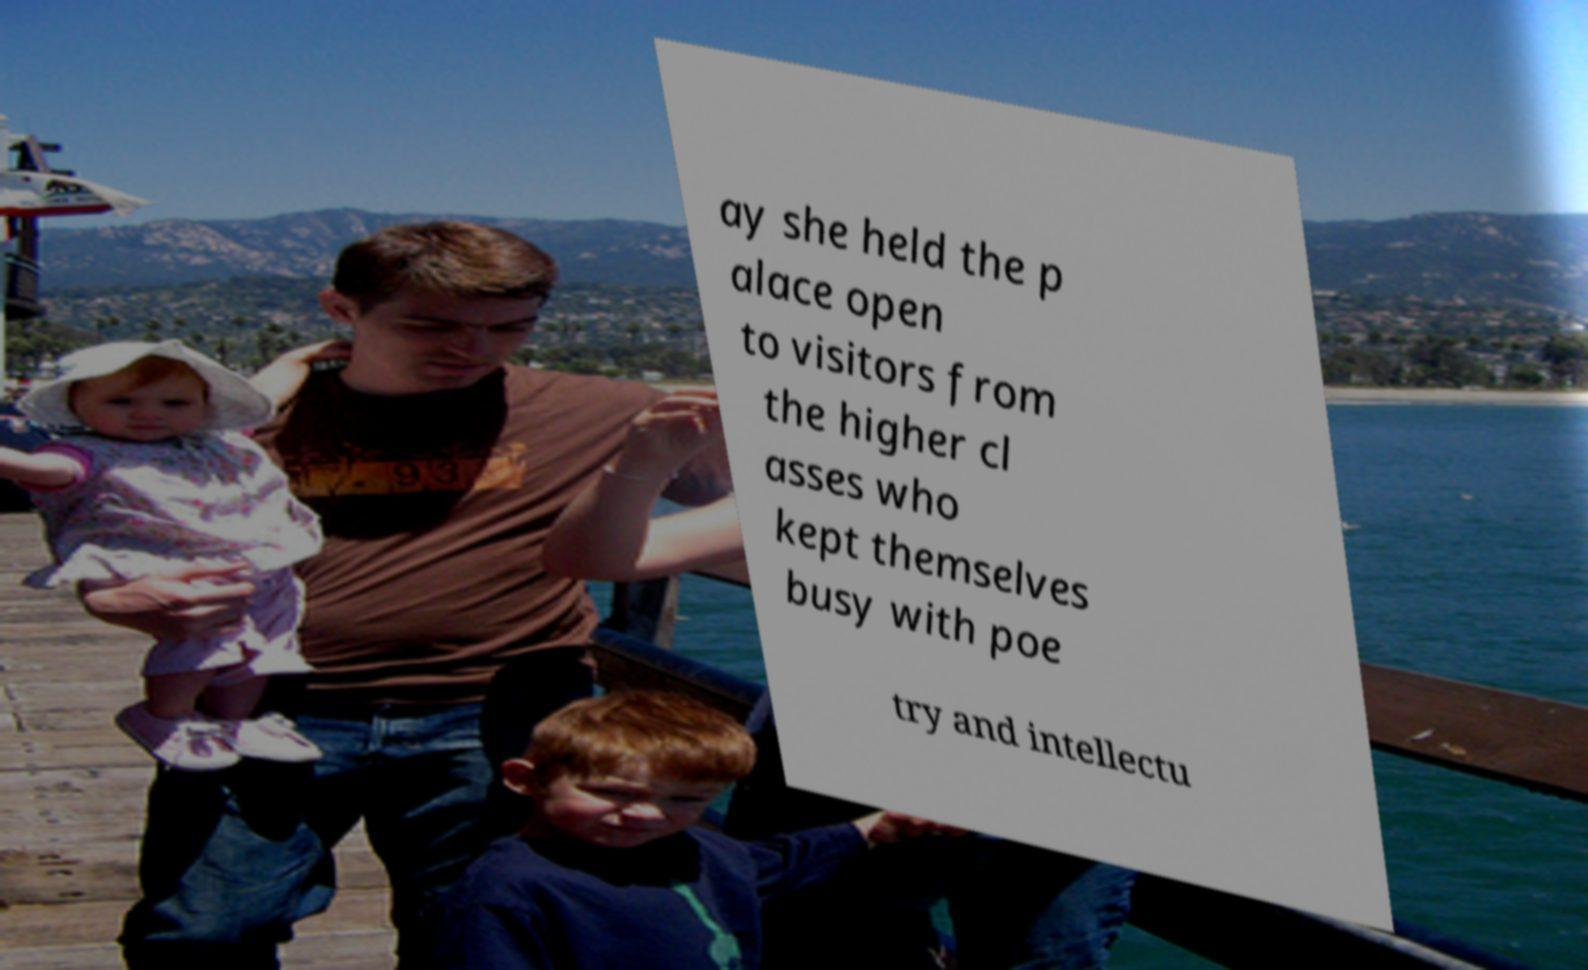Please read and relay the text visible in this image. What does it say? ay she held the p alace open to visitors from the higher cl asses who kept themselves busy with poe try and intellectu 